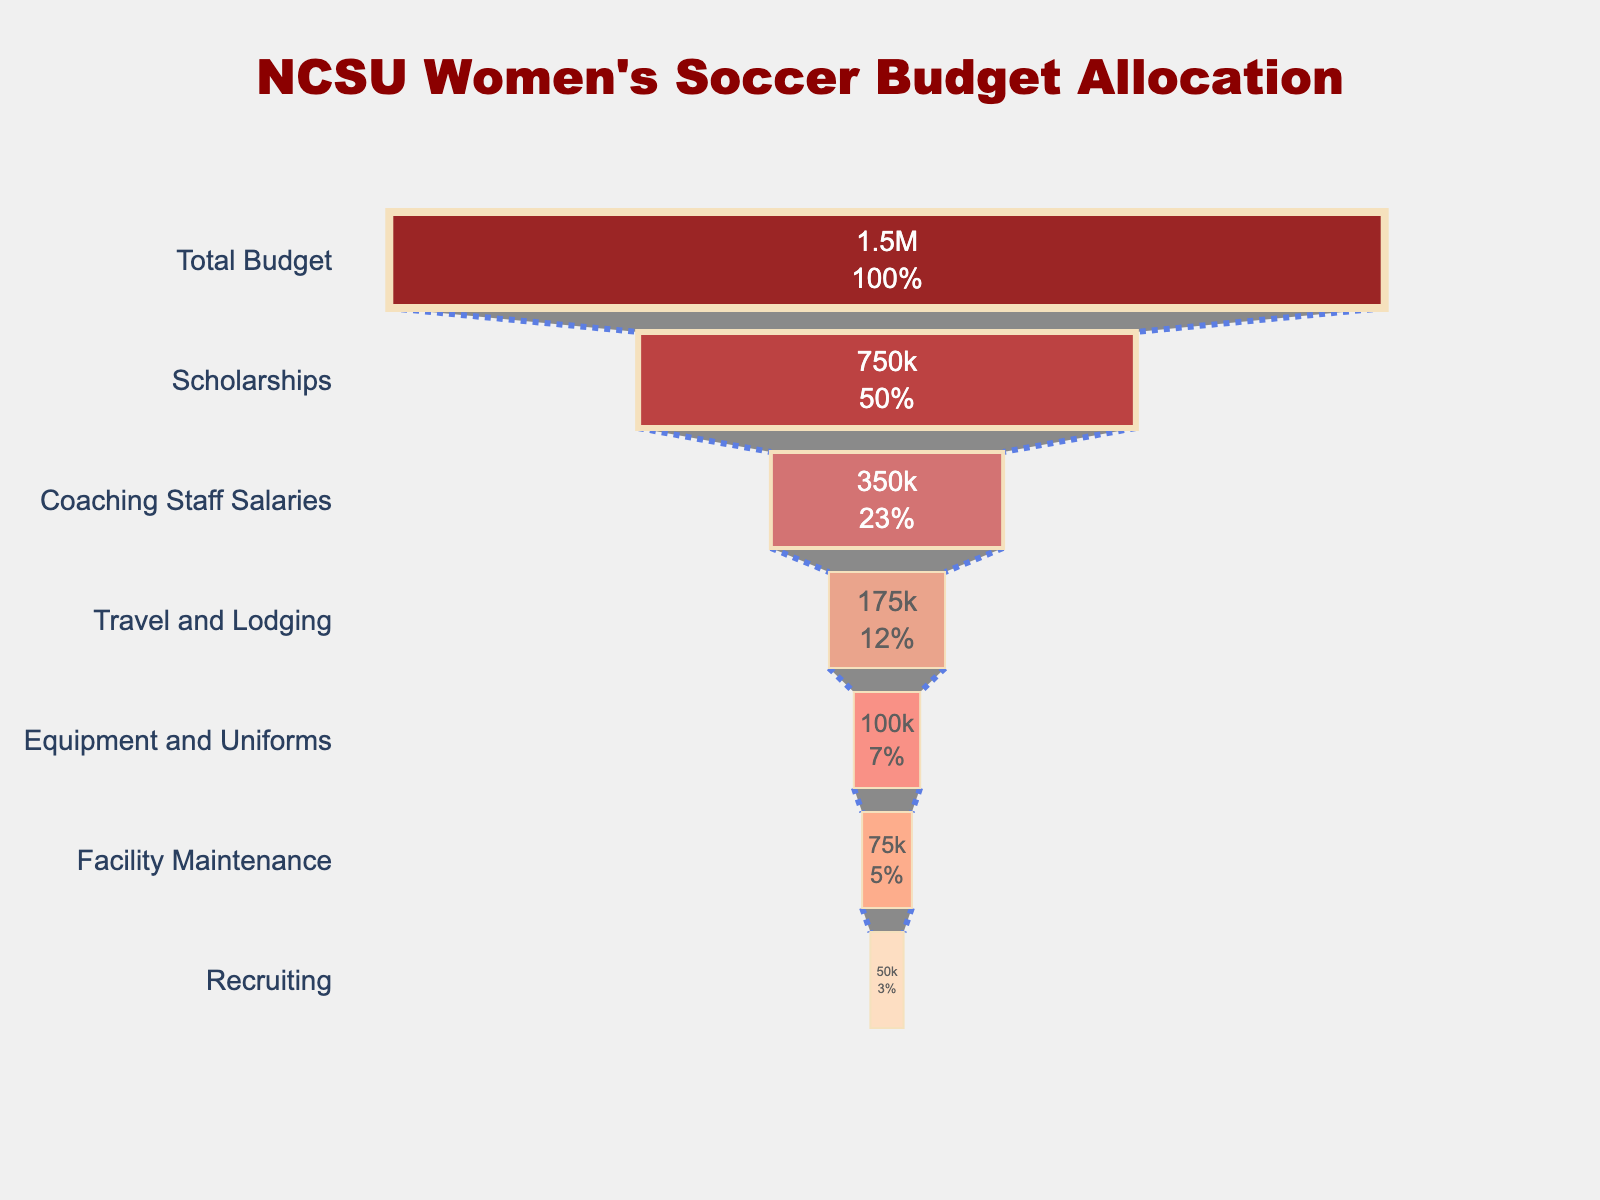How much of the total budget is allocated to scholarships? From the funnel chart, the amount allocated to scholarships is listed directly as 750,000.
Answer: 750,000 What percentage of the total budget is allocated to coaching staff salaries? The total budget is 1,500,000, and the amount for coaching staff salaries is 350,000. The percentage is (350,000 / 1,500,000) * 100 = 23.33%.
Answer: 23.33% Between travel and lodging and equipment and uniforms, which category has a higher budget allocation? The funnel chart shows 175,000 for travel and lodging and 100,000 for equipment and uniforms. 175,000 is greater than 100,000.
Answer: Travel and Lodging What is the combined budget for facility maintenance and recruiting? From the funnel chart, facility maintenance is 75,000, and recruiting is 50,000. Adding them together: 75,000 + 50,000 = 125,000.
Answer: 125,000 Which category has the smallest budget allocation? The smallest number in the funnel chart is for recruiting, at 50,000.
Answer: Recruiting Are scholarships alone allocated more than half of the total budget? Scholarships are 750,000. Half of the total budget (1,500,000) is 750,000. Since scholarships equal 750,000, it's exactly half, not more.
Answer: No What is the median value of the budget allocations excluding the total budget? Excluding the total budget, the values are 750,000, 350,000, 175,000, 100,000, 75,000, and 50,000. Sorting these: 50,000, 75,000, 100,000, 175,000, 350,000, 750,000. The median is the average of the middle two values, (175,000 + 100,000) / 2 = 137,500.
Answer: 137,500 How does the amount allocated to equipment and uniforms compare with that for facility maintenance? Equipment and Uniforms have 100,000, while Facility Maintenance has 75,000 according to the chart. 100,000 is greater than 75,000.
Answer: Equipment and Uniforms By what factor is the amount for scholarships larger than recruiting? Scholarships amount to 750,000 and recruiting amounts to 50,000. The factor is 750,000 / 50,000 = 15.
Answer: 15 What is the difference in budget allocation between the highest and lowest categories? The highest category is scholarships at 750,000, and the lowest is recruiting at 50,000. The difference is 750,000 - 50,000 = 700,000.
Answer: 700,000 